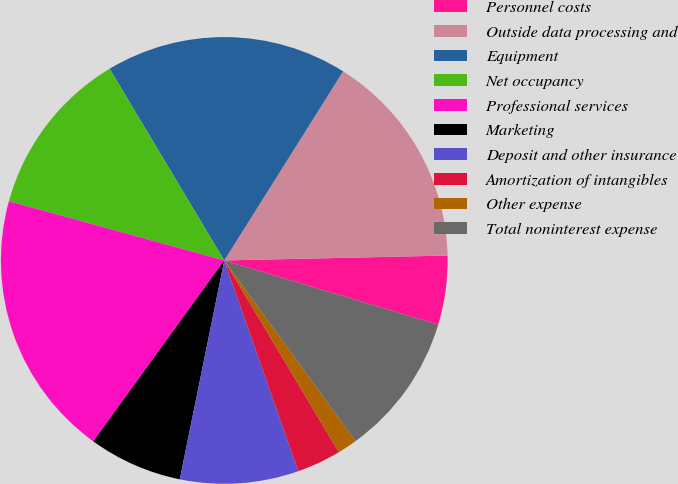Convert chart. <chart><loc_0><loc_0><loc_500><loc_500><pie_chart><fcel>Personnel costs<fcel>Outside data processing and<fcel>Equipment<fcel>Net occupancy<fcel>Professional services<fcel>Marketing<fcel>Deposit and other insurance<fcel>Amortization of intangibles<fcel>Other expense<fcel>Total noninterest expense<nl><fcel>4.99%<fcel>15.72%<fcel>17.51%<fcel>12.15%<fcel>19.3%<fcel>6.78%<fcel>8.57%<fcel>3.2%<fcel>1.42%<fcel>10.36%<nl></chart> 